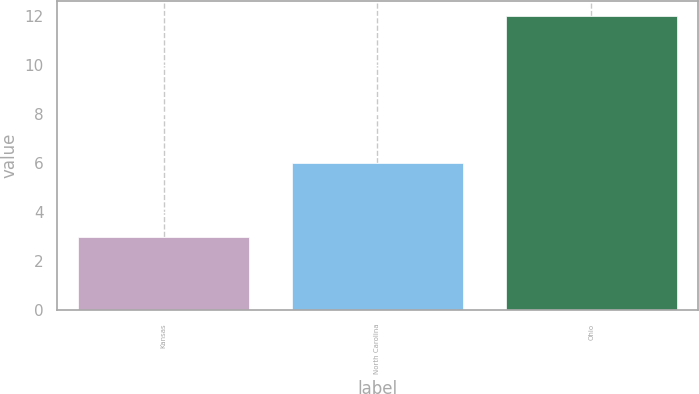Convert chart to OTSL. <chart><loc_0><loc_0><loc_500><loc_500><bar_chart><fcel>Kansas<fcel>North Carolina<fcel>Ohio<nl><fcel>3<fcel>6<fcel>12<nl></chart> 